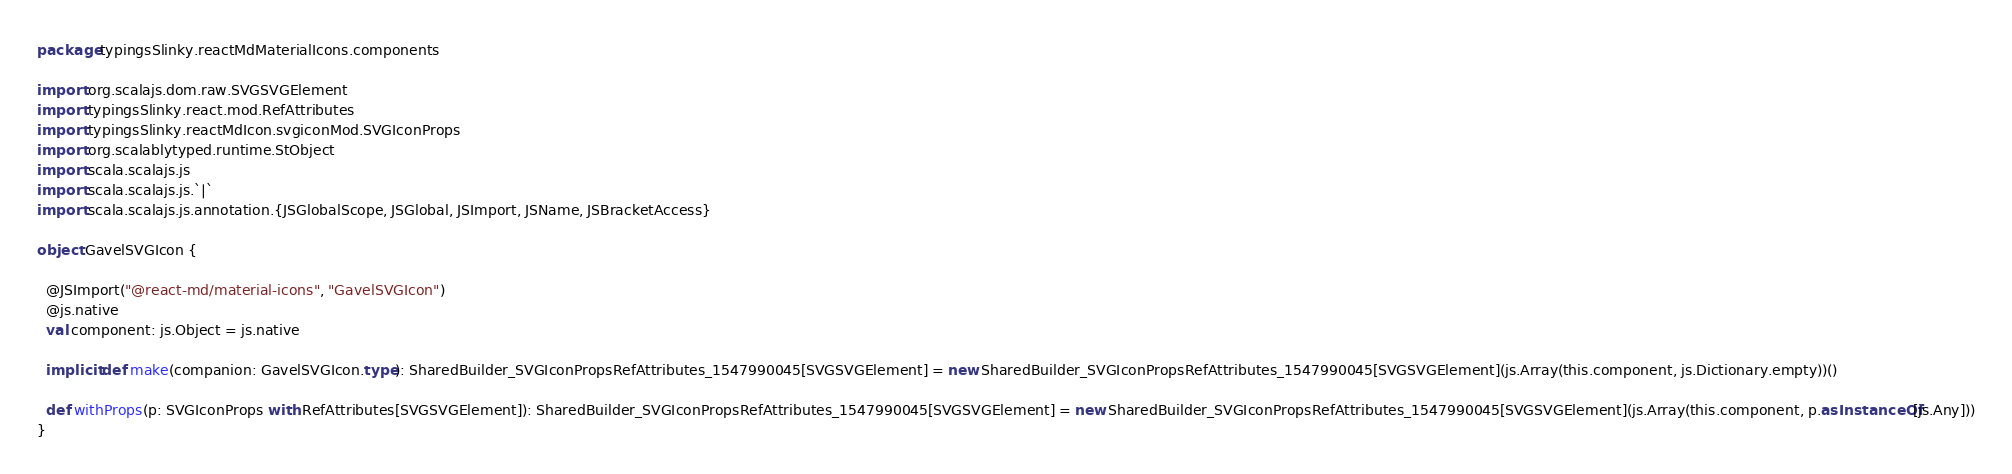Convert code to text. <code><loc_0><loc_0><loc_500><loc_500><_Scala_>package typingsSlinky.reactMdMaterialIcons.components

import org.scalajs.dom.raw.SVGSVGElement
import typingsSlinky.react.mod.RefAttributes
import typingsSlinky.reactMdIcon.svgiconMod.SVGIconProps
import org.scalablytyped.runtime.StObject
import scala.scalajs.js
import scala.scalajs.js.`|`
import scala.scalajs.js.annotation.{JSGlobalScope, JSGlobal, JSImport, JSName, JSBracketAccess}

object GavelSVGIcon {
  
  @JSImport("@react-md/material-icons", "GavelSVGIcon")
  @js.native
  val component: js.Object = js.native
  
  implicit def make(companion: GavelSVGIcon.type): SharedBuilder_SVGIconPropsRefAttributes_1547990045[SVGSVGElement] = new SharedBuilder_SVGIconPropsRefAttributes_1547990045[SVGSVGElement](js.Array(this.component, js.Dictionary.empty))()
  
  def withProps(p: SVGIconProps with RefAttributes[SVGSVGElement]): SharedBuilder_SVGIconPropsRefAttributes_1547990045[SVGSVGElement] = new SharedBuilder_SVGIconPropsRefAttributes_1547990045[SVGSVGElement](js.Array(this.component, p.asInstanceOf[js.Any]))
}
</code> 